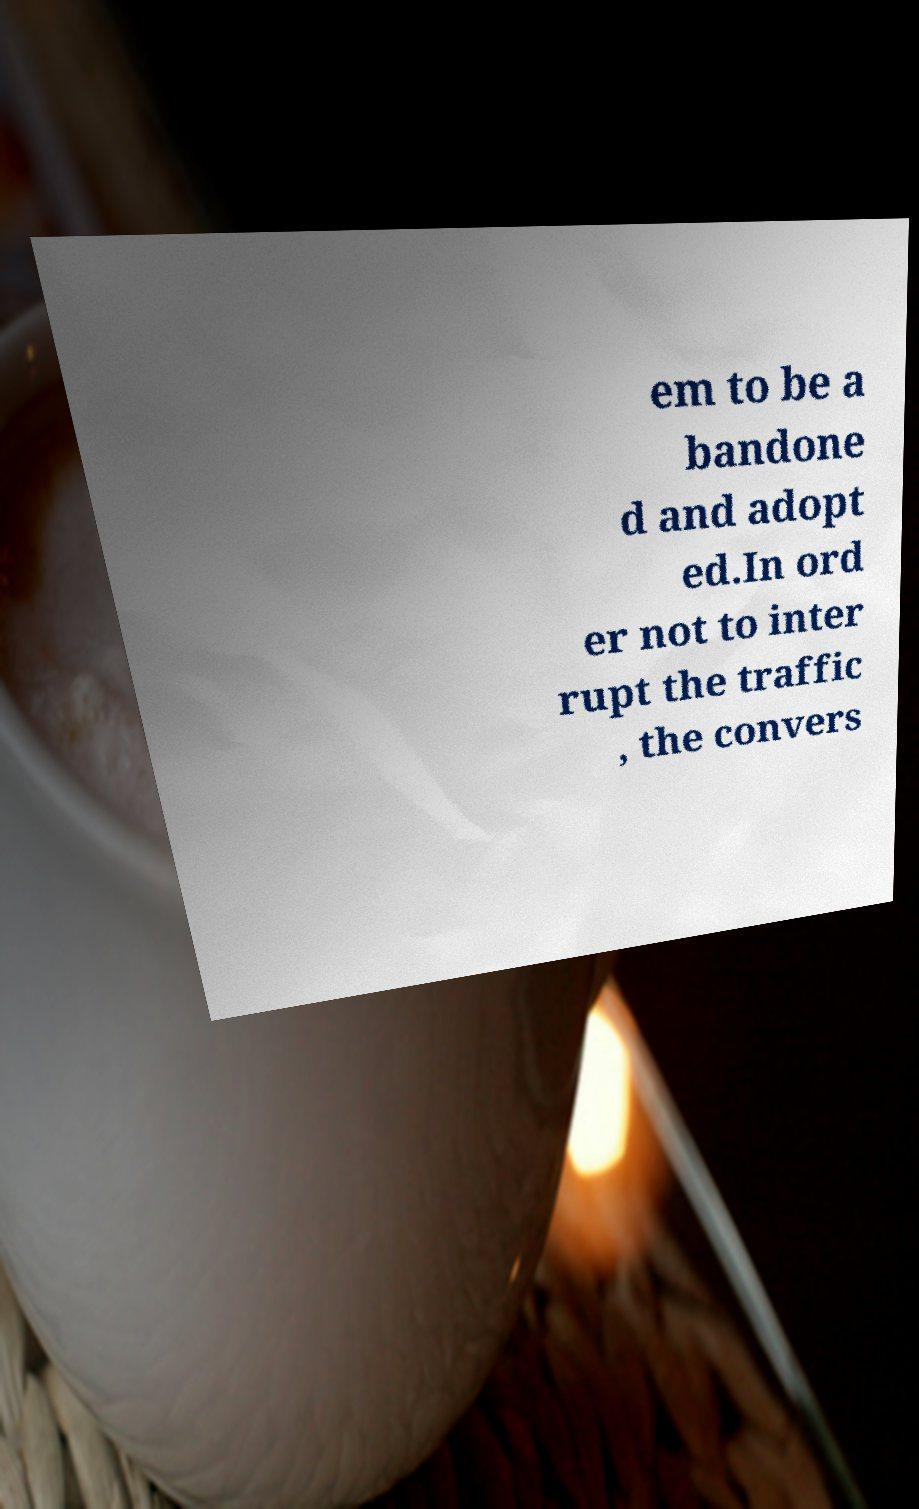Please read and relay the text visible in this image. What does it say? em to be a bandone d and adopt ed.In ord er not to inter rupt the traffic , the convers 